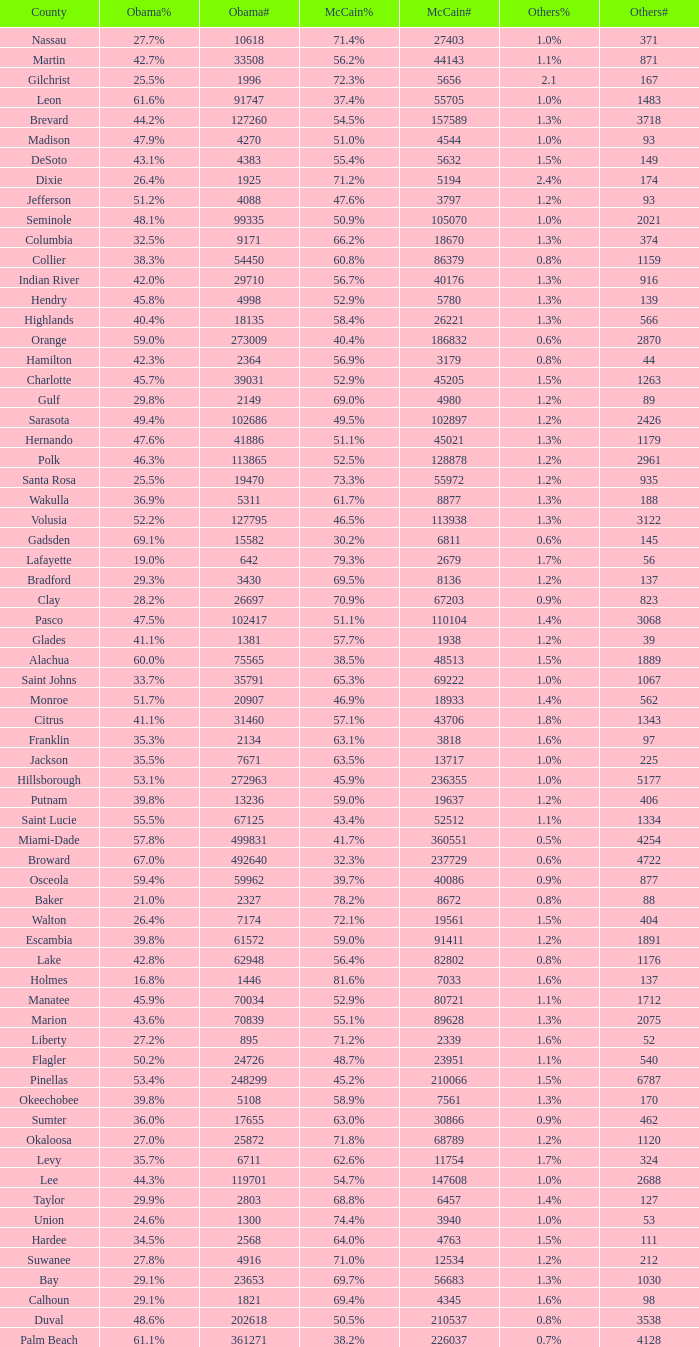What percentage was the others vote when McCain had 52.9% and less than 45205.0 voters? 1.3%. 